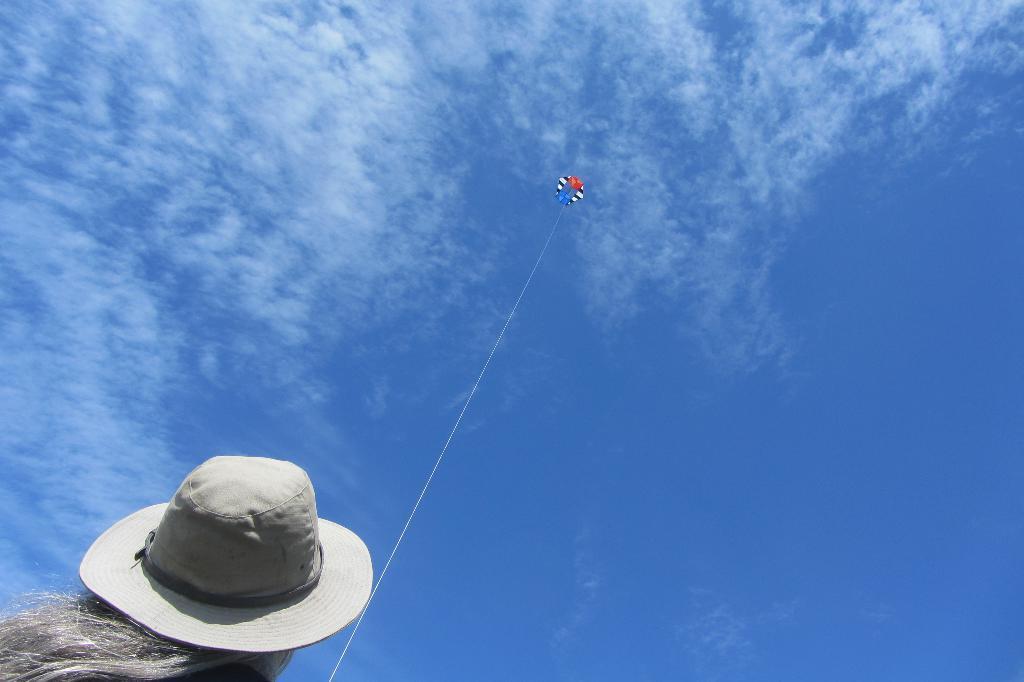Describe this image in one or two sentences. In this picture there is a girl at the bottom side of the image, she is flying the kite. 